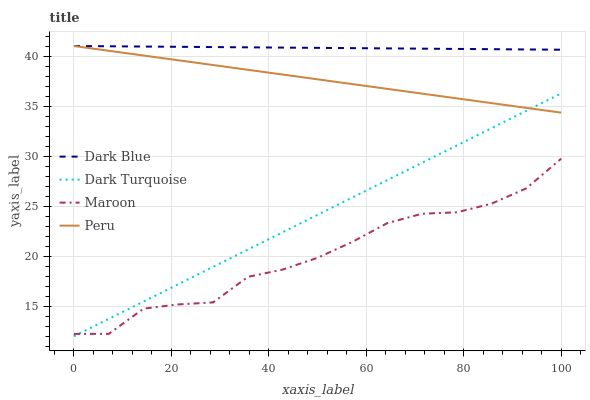Does Maroon have the minimum area under the curve?
Answer yes or no. Yes. Does Dark Blue have the maximum area under the curve?
Answer yes or no. Yes. Does Peru have the minimum area under the curve?
Answer yes or no. No. Does Peru have the maximum area under the curve?
Answer yes or no. No. Is Dark Turquoise the smoothest?
Answer yes or no. Yes. Is Maroon the roughest?
Answer yes or no. Yes. Is Peru the smoothest?
Answer yes or no. No. Is Peru the roughest?
Answer yes or no. No. Does Dark Turquoise have the lowest value?
Answer yes or no. Yes. Does Peru have the lowest value?
Answer yes or no. No. Does Peru have the highest value?
Answer yes or no. Yes. Does Maroon have the highest value?
Answer yes or no. No. Is Dark Turquoise less than Dark Blue?
Answer yes or no. Yes. Is Dark Blue greater than Dark Turquoise?
Answer yes or no. Yes. Does Maroon intersect Dark Turquoise?
Answer yes or no. Yes. Is Maroon less than Dark Turquoise?
Answer yes or no. No. Is Maroon greater than Dark Turquoise?
Answer yes or no. No. Does Dark Turquoise intersect Dark Blue?
Answer yes or no. No. 